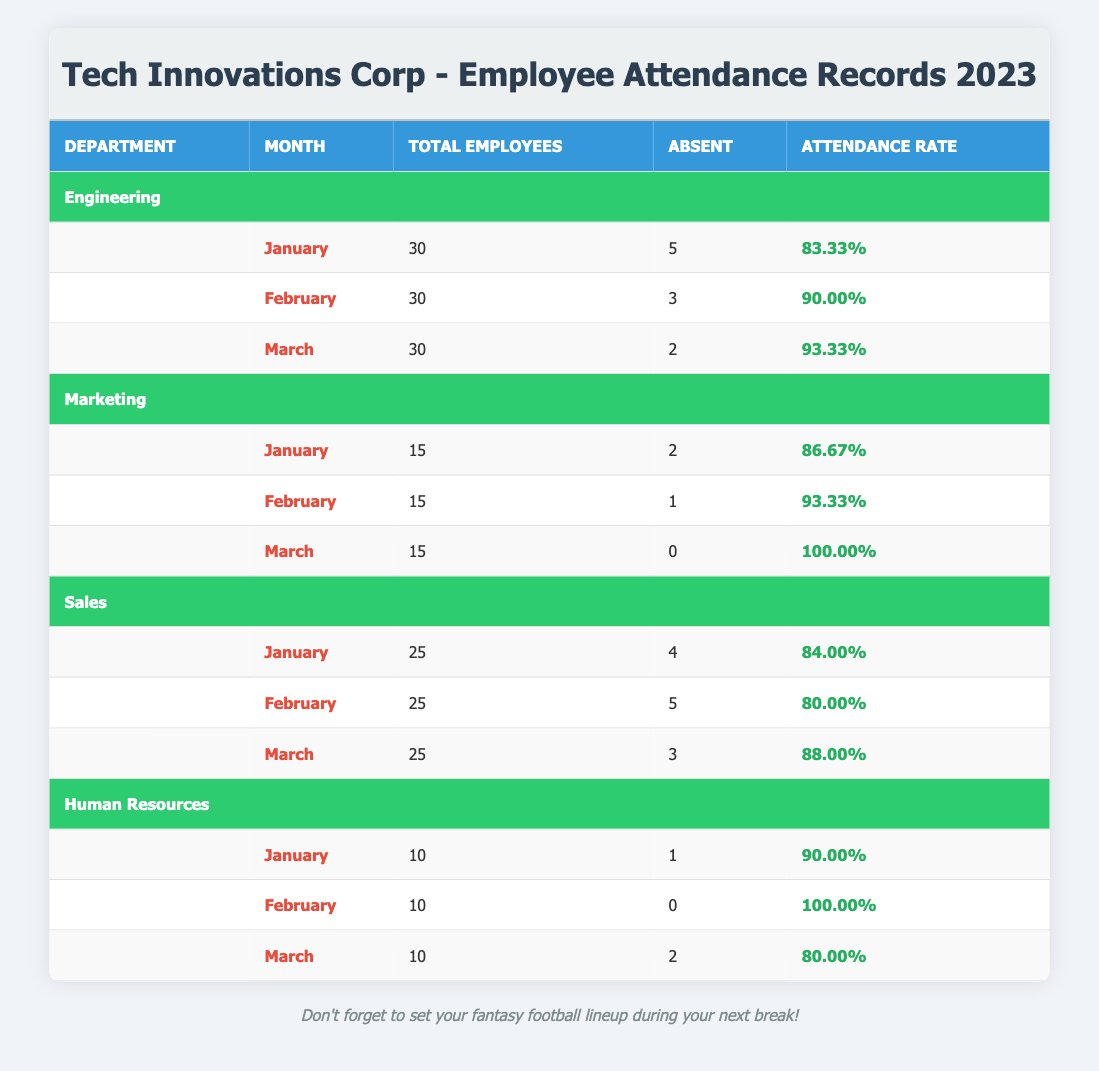What is the attendance rate for the Engineering department in February? The attendance rate is listed under the February row for the Engineering department, which states "90.00%".
Answer: 90.00% How many total employees were absent in the Marketing department in March? The table shows that in March, the Marketing department had "0" absentees.
Answer: 0 Which department had the highest attendance rate in March? The March attendance rates are: Engineering 93.33%, Marketing 100.00%, Sales 88.00%, and Human Resources 80.00%. Marketing has the highest at 100.00%.
Answer: Marketing What is the average attendance rate across all departments for January? The attendance rates for January are: Engineering 83.33%, Marketing 86.67%, Sales 84.00%, and Human Resources 90.00%. The average is calculated as (83.33 + 86.67 + 84.00 + 90.00) / 4 = 86.00%.
Answer: 86.00% Did the Sales department improve its attendance rate from February to March? The attendance rates show that in February, Sales had a rate of 80.00%, and in March it increased to 88.00%. This is an improvement.
Answer: Yes What is the total number of absences recorded for the Human Resources department in the first quarter? The table lists absences for Human Resources as: January 1, February 0, and March 2. The total is calculated as 1 + 0 + 2 = 3 absences.
Answer: 3 In which month did the Engineering department have its highest attendance rate? By examining the attendance rates for Engineering: January 83.33%, February 90.00%, and March 93.33%, it is clear that March has the highest rate at 93.33%.
Answer: March Is it true that the Marketing department had more absences in January than in February? The table indicates that in January, Marketing had 2 absences and in February had only 1 absence. This means it is false that they had more absences in January than February.
Answer: No What was the total number of employees across all departments in February? The total number of employees is calculated from each department for February: Engineering 30, Marketing 15, Sales 25, Human Resources 10, which gives 30 + 15 + 25 + 10 = 80 total employees.
Answer: 80 